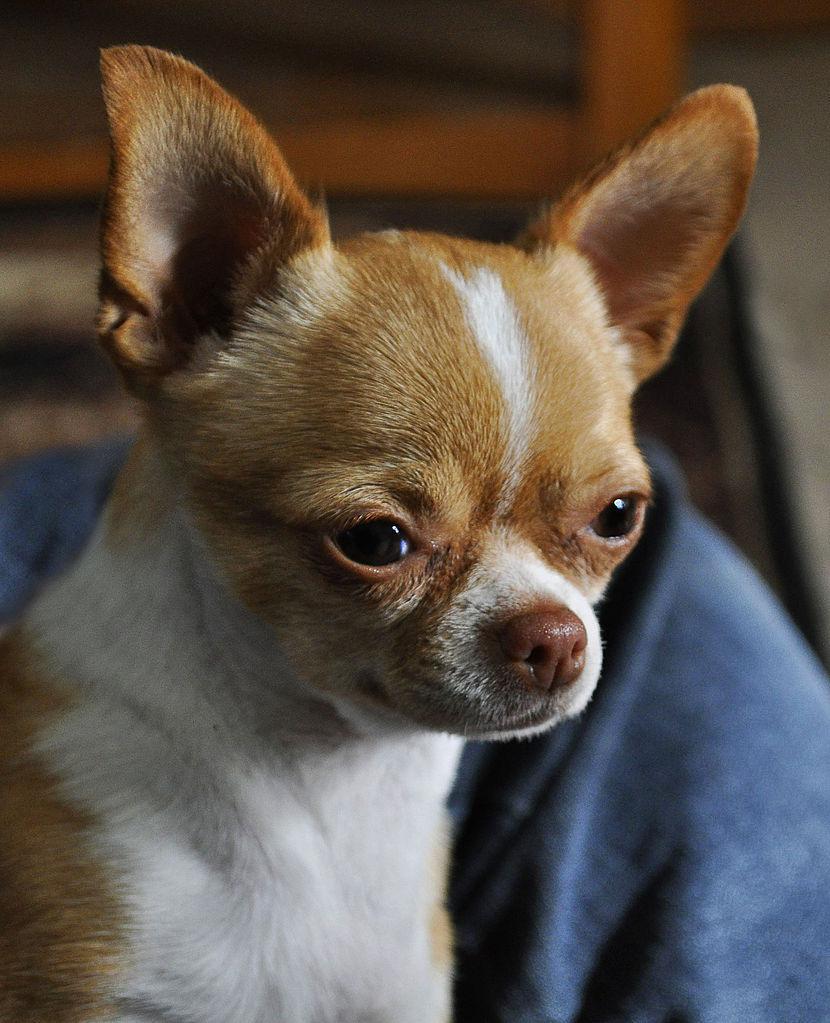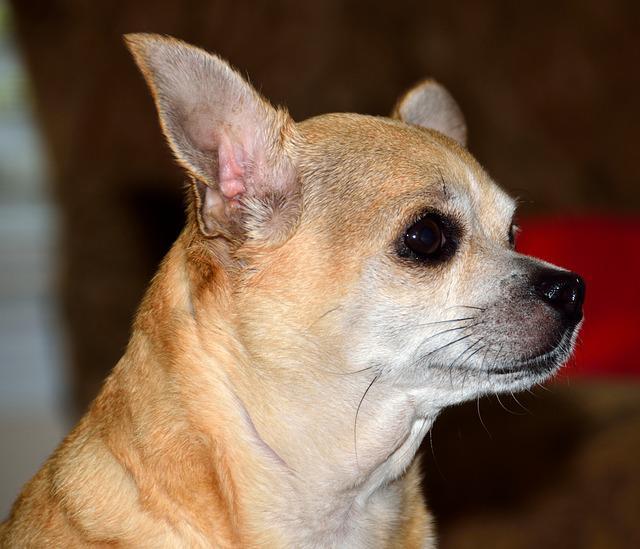The first image is the image on the left, the second image is the image on the right. Given the left and right images, does the statement "the dog on the right image has its mouth open" hold true? Answer yes or no. No. 